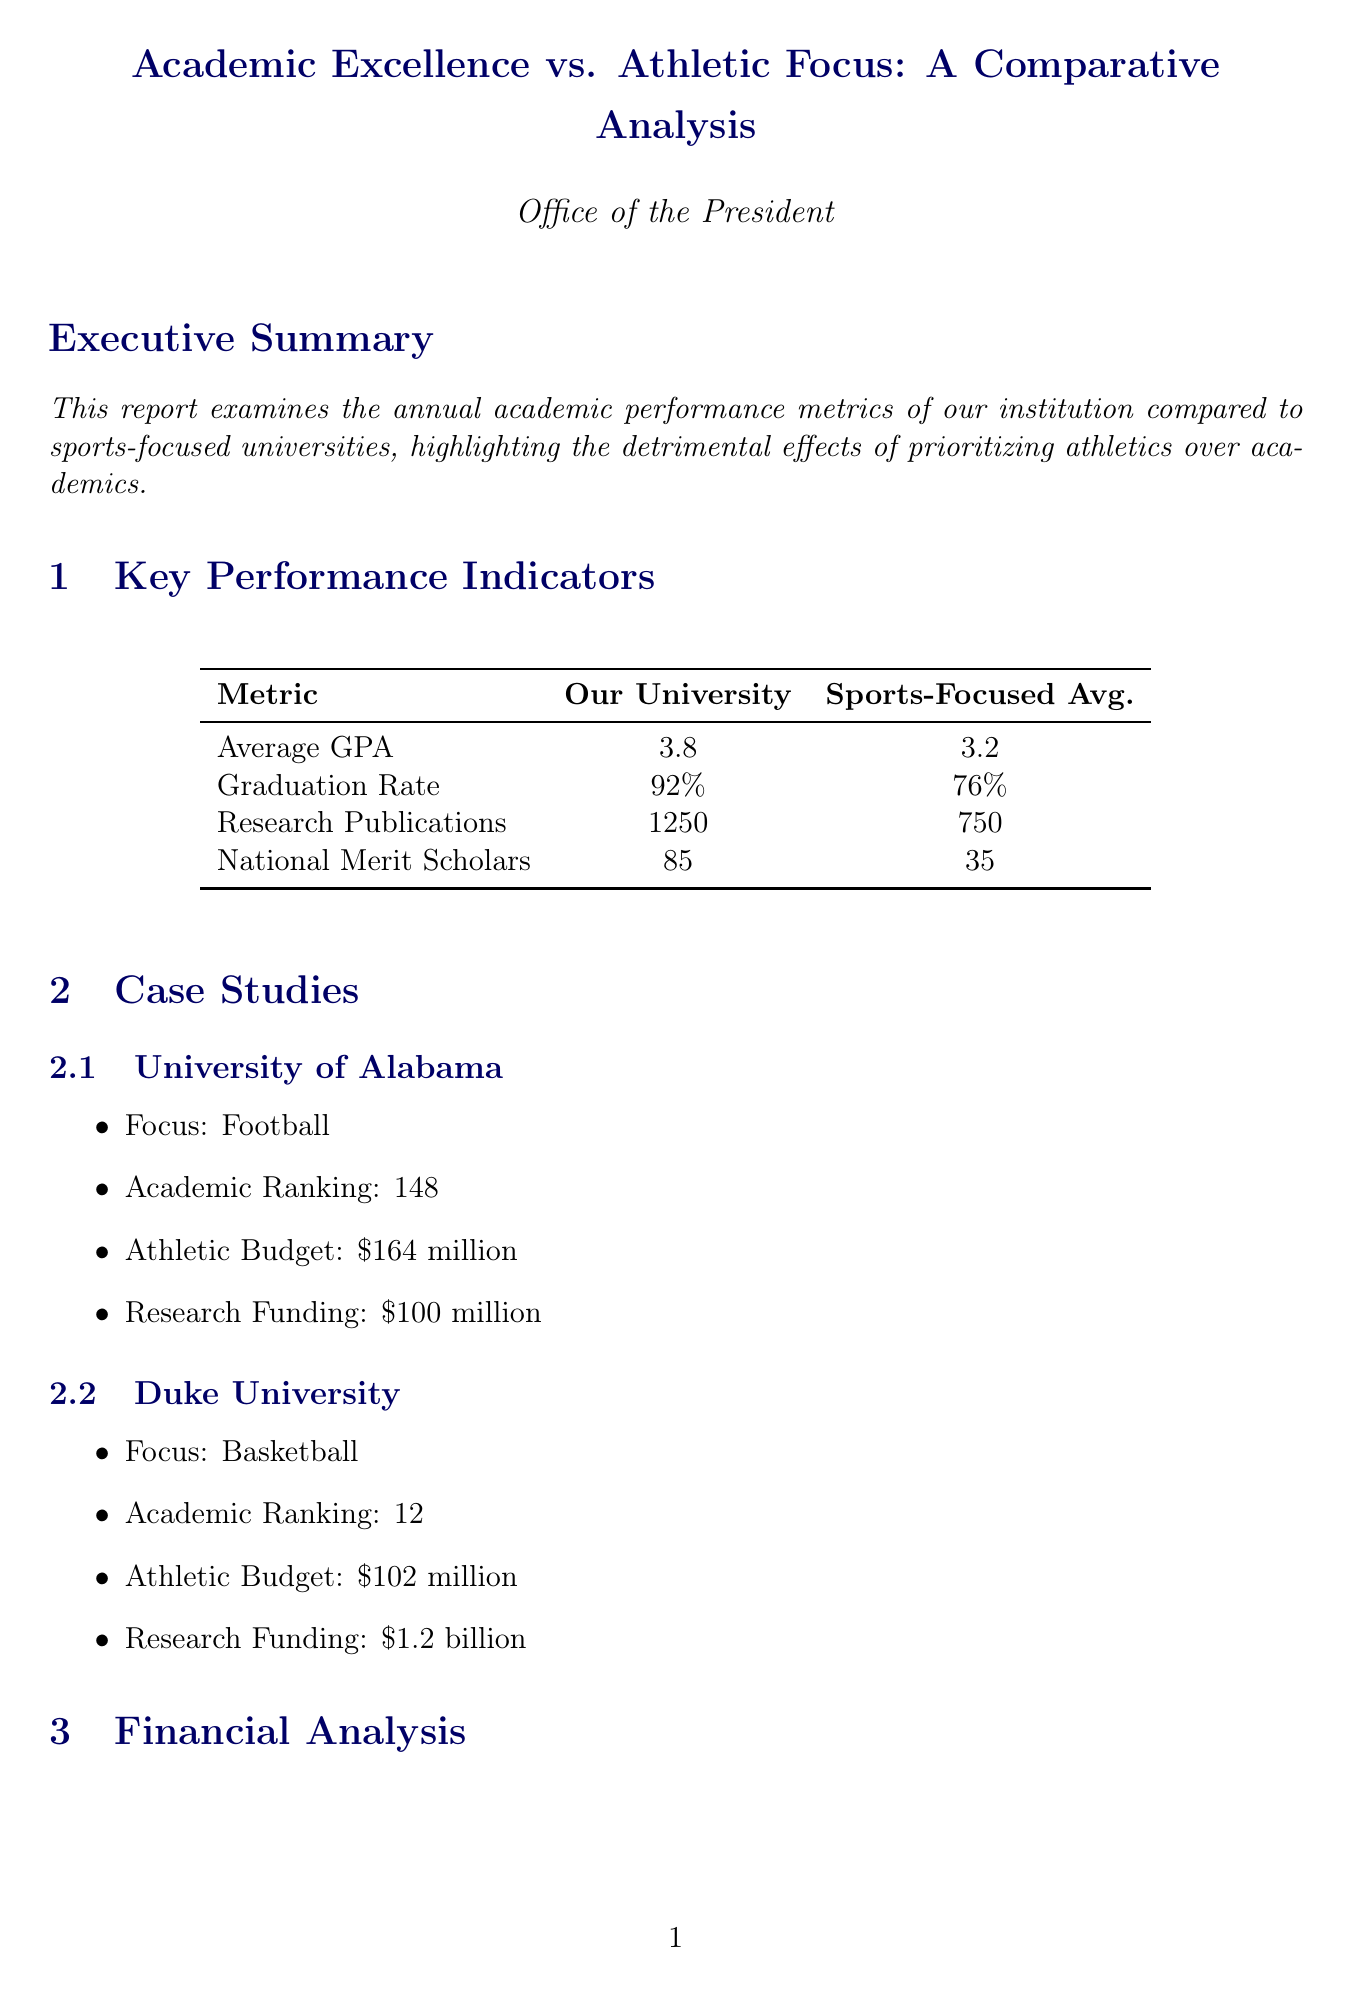What is the average GPA of our university? The average GPA of our university is listed in the key performance indicators section.
Answer: 3.8 What is the graduation rate for sports-focused universities? The graduation rate for sports-focused universities is provided in the comparison table.
Answer: 76% How many research publications does our university have? The number of research publications for our university is found in the key performance indicators.
Answer: 1250 What is the athletic budget of Duke University? The athletic budget for Duke University is mentioned in the case studies section.
Answer: $102 million How many Nobel laureates does our university have? The number of Nobel laureates is given in the faculty recognition section.
Answer: 3 What is the research funding for the University of Alabama? The research funding for the University of Alabama is included in the case studies section.
Answer: $100 million What is the average starting salary for graduates from our university? The average starting salary is highlighted in the post-graduation outcomes section.
Answer: $75,000 Which type of scholars does our university have more compared to sports-focused universities? The document discusses specific types of scholars and their counts.
Answer: Rhodes Scholars What does the report conclude about academic excellence versus athletics? The conclusion outlines the overall message of the report regarding focus areas.
Answer: Focus on academic excellence yields superior results 